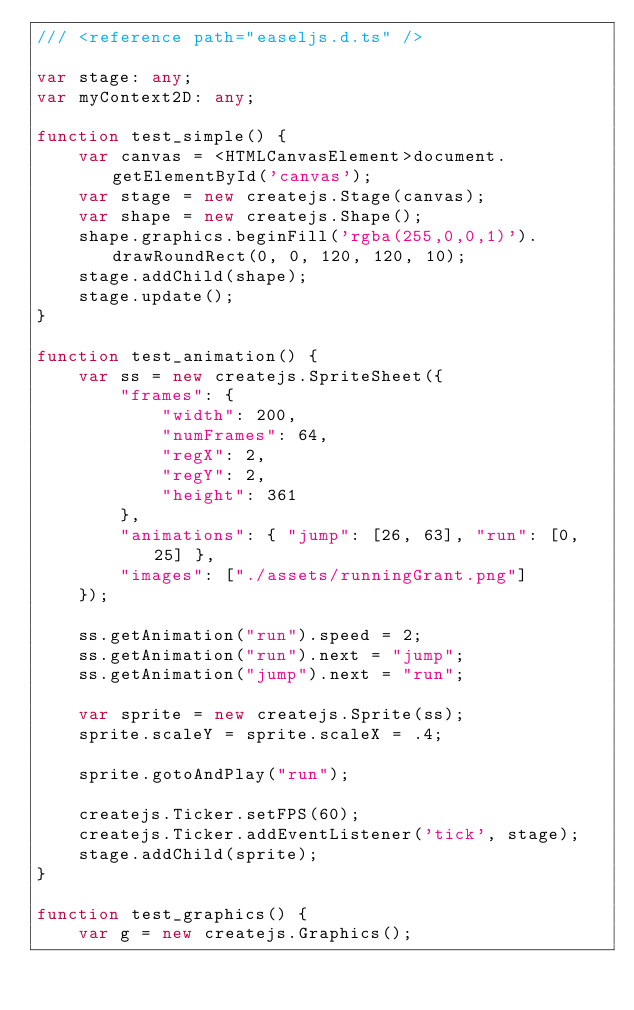Convert code to text. <code><loc_0><loc_0><loc_500><loc_500><_TypeScript_>/// <reference path="easeljs.d.ts" />

var stage: any;
var myContext2D: any;

function test_simple() {
    var canvas = <HTMLCanvasElement>document.getElementById('canvas');
    var stage = new createjs.Stage(canvas);
    var shape = new createjs.Shape();
    shape.graphics.beginFill('rgba(255,0,0,1)').drawRoundRect(0, 0, 120, 120, 10);
    stage.addChild(shape);
    stage.update();
}

function test_animation() {
    var ss = new createjs.SpriteSheet({
        "frames": {
            "width": 200,
            "numFrames": 64,
            "regX": 2,
            "regY": 2,
            "height": 361
        },
        "animations": { "jump": [26, 63], "run": [0, 25] },
        "images": ["./assets/runningGrant.png"]
    });

    ss.getAnimation("run").speed = 2;
    ss.getAnimation("run").next = "jump";
    ss.getAnimation("jump").next = "run";

    var sprite = new createjs.Sprite(ss);
    sprite.scaleY = sprite.scaleX = .4;

    sprite.gotoAndPlay("run");

    createjs.Ticker.setFPS(60);
    createjs.Ticker.addEventListener('tick', stage);
    stage.addChild(sprite);
}

function test_graphics() {
    var g = new createjs.Graphics();</code> 